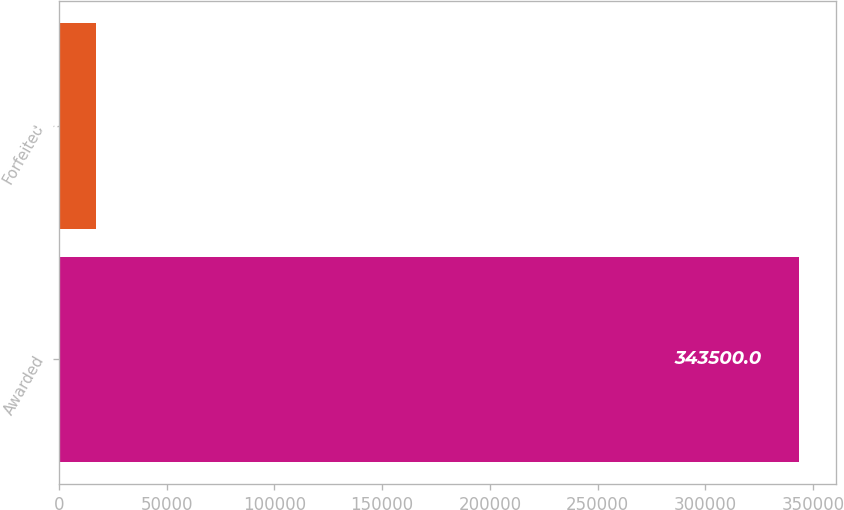<chart> <loc_0><loc_0><loc_500><loc_500><bar_chart><fcel>Awarded<fcel>Forfeited<nl><fcel>343500<fcel>17438<nl></chart> 